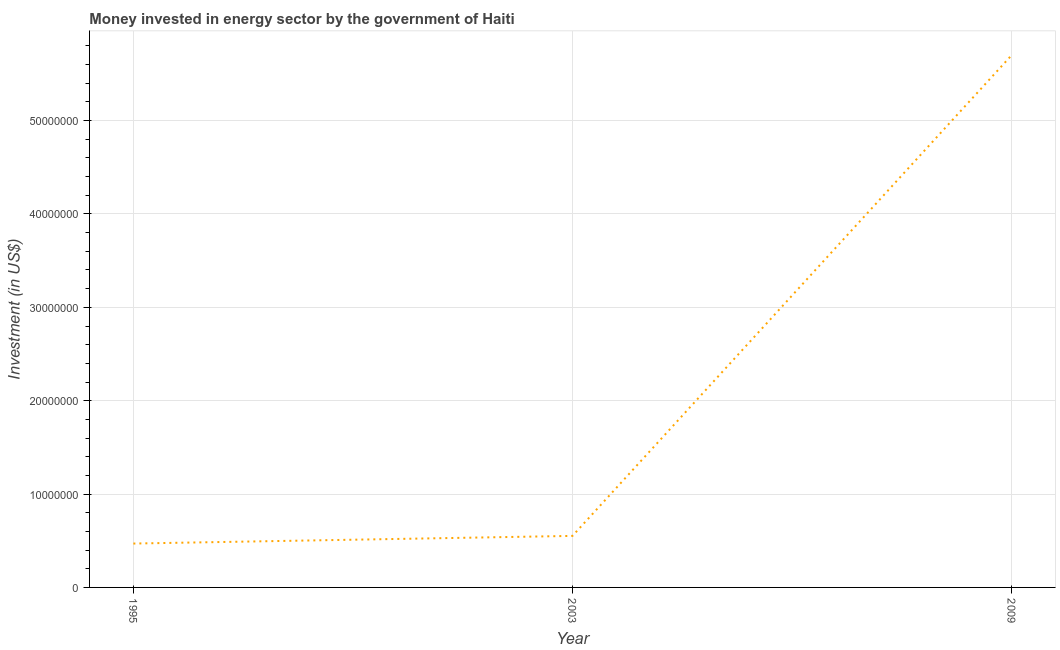What is the investment in energy in 2003?
Provide a short and direct response. 5.52e+06. Across all years, what is the maximum investment in energy?
Keep it short and to the point. 5.70e+07. Across all years, what is the minimum investment in energy?
Your answer should be compact. 4.70e+06. What is the sum of the investment in energy?
Keep it short and to the point. 6.72e+07. What is the difference between the investment in energy in 1995 and 2009?
Offer a terse response. -5.23e+07. What is the average investment in energy per year?
Ensure brevity in your answer.  2.24e+07. What is the median investment in energy?
Provide a succinct answer. 5.52e+06. In how many years, is the investment in energy greater than 6000000 US$?
Keep it short and to the point. 1. Do a majority of the years between 1995 and 2003 (inclusive) have investment in energy greater than 32000000 US$?
Your answer should be very brief. No. What is the ratio of the investment in energy in 1995 to that in 2003?
Offer a very short reply. 0.85. What is the difference between the highest and the second highest investment in energy?
Keep it short and to the point. 5.15e+07. Is the sum of the investment in energy in 2003 and 2009 greater than the maximum investment in energy across all years?
Ensure brevity in your answer.  Yes. What is the difference between the highest and the lowest investment in energy?
Provide a succinct answer. 5.23e+07. In how many years, is the investment in energy greater than the average investment in energy taken over all years?
Offer a very short reply. 1. Does the investment in energy monotonically increase over the years?
Your response must be concise. Yes. What is the difference between two consecutive major ticks on the Y-axis?
Make the answer very short. 1.00e+07. Does the graph contain grids?
Your answer should be very brief. Yes. What is the title of the graph?
Your answer should be very brief. Money invested in energy sector by the government of Haiti. What is the label or title of the X-axis?
Offer a very short reply. Year. What is the label or title of the Y-axis?
Offer a very short reply. Investment (in US$). What is the Investment (in US$) of 1995?
Offer a very short reply. 4.70e+06. What is the Investment (in US$) of 2003?
Make the answer very short. 5.52e+06. What is the Investment (in US$) of 2009?
Offer a terse response. 5.70e+07. What is the difference between the Investment (in US$) in 1995 and 2003?
Your answer should be compact. -8.20e+05. What is the difference between the Investment (in US$) in 1995 and 2009?
Your answer should be very brief. -5.23e+07. What is the difference between the Investment (in US$) in 2003 and 2009?
Give a very brief answer. -5.15e+07. What is the ratio of the Investment (in US$) in 1995 to that in 2003?
Offer a very short reply. 0.85. What is the ratio of the Investment (in US$) in 1995 to that in 2009?
Your answer should be very brief. 0.08. What is the ratio of the Investment (in US$) in 2003 to that in 2009?
Your answer should be very brief. 0.1. 